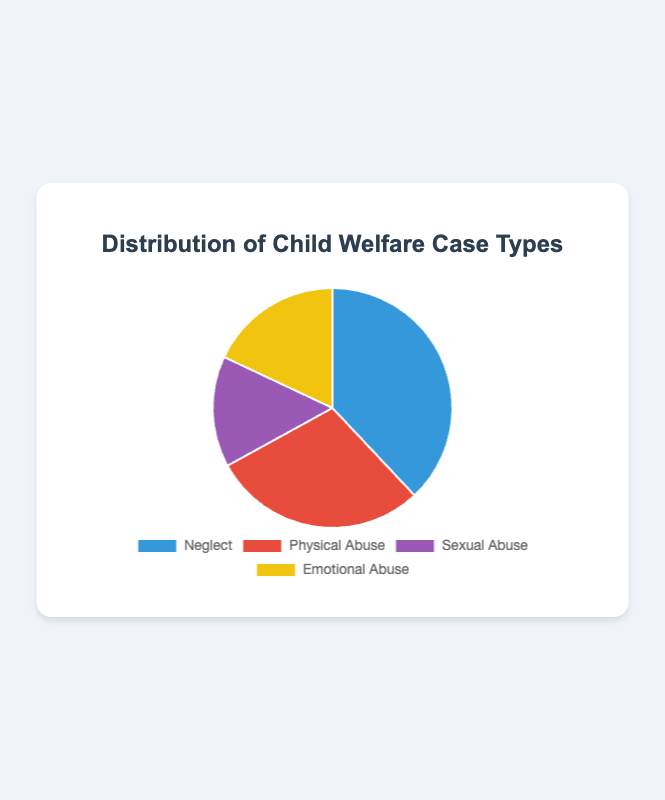What percentage of cases are categorized as Physical Abuse? According to the pie chart, Physical Abuse constitutes 29% of the total cases.
Answer: 29% What is the least common case type shown in the pie chart? The pie chart shows four case types with their respective percentages: Neglect (38%), Physical Abuse (29%), Sexual Abuse (15%), and Emotional Abuse (18%). The smallest percentage is for Sexual Abuse, at 15%.
Answer: Sexual Abuse How much greater is the percentage of Neglect cases compared to Sexual Abuse cases? The percentage of Neglect cases is 38% and Sexual Abuse cases is 15%. The difference is 38% - 15% = 23%.
Answer: 23% Which case type is represented in yellow on the pie chart? Observing the pie chart, the color allocations are: blue for Neglect, red for Physical Abuse, purple for Sexual Abuse, and yellow for Emotional Abuse. Thus, the category represented in yellow is Emotional Abuse.
Answer: Emotional Abuse What is the total percentage of cases categorized as either Neglect or Emotional Abuse? The percentage of Neglect cases is 38%, and the percentage of Emotional Abuse cases is 18%. The combined total is 38% + 18% = 56%.
Answer: 56% How does the percentage of Emotional Abuse cases compare to the percentage of Sexual Abuse cases? Emotional Abuse makes up 18% of the cases, while Sexual Abuse accounts for 15%. Emotional Abuse is greater by 18% - 15% = 3%.
Answer: Emotional Abuse is greater by 3% What colors represent Neglect and Physical Abuse in the pie chart respectively? The pie chart uses blue for Neglect and red for Physical Abuse.
Answer: Blue and Red What is the difference in the number of Neglect cases between the North and South regions? North Region has 120 Neglect cases, and South Region has 150 Neglect cases. The difference is 150 - 120 = 30 cases.
Answer: 30 cases Which region has the highest number of Physical Abuse cases, and how many does it have? The East Region has the highest number of Physical Abuse cases with 180 cases. The numbers for other regions are 90 (North), 130 (South), and 150 (West).
Answer: East Region with 180 cases Calculate the average number of Emotional Abuse cases across all regions. There are 60 Emotional Abuse cases in the North, 120 in the South, 90 in the East, and 50 in the West, making the total 60+120+90+50 = 320 cases. The average is 320 / 4 = 80 cases.
Answer: 80 cases 